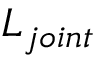<formula> <loc_0><loc_0><loc_500><loc_500>L _ { j o i n t }</formula> 